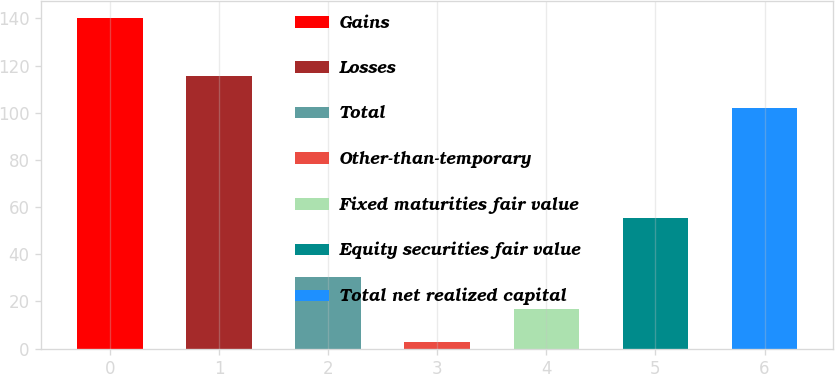<chart> <loc_0><loc_0><loc_500><loc_500><bar_chart><fcel>Gains<fcel>Losses<fcel>Total<fcel>Other-than-temporary<fcel>Fixed maturities fair value<fcel>Equity securities fair value<fcel>Total net realized capital<nl><fcel>140.2<fcel>115.62<fcel>30.44<fcel>3<fcel>16.72<fcel>55.3<fcel>101.9<nl></chart> 